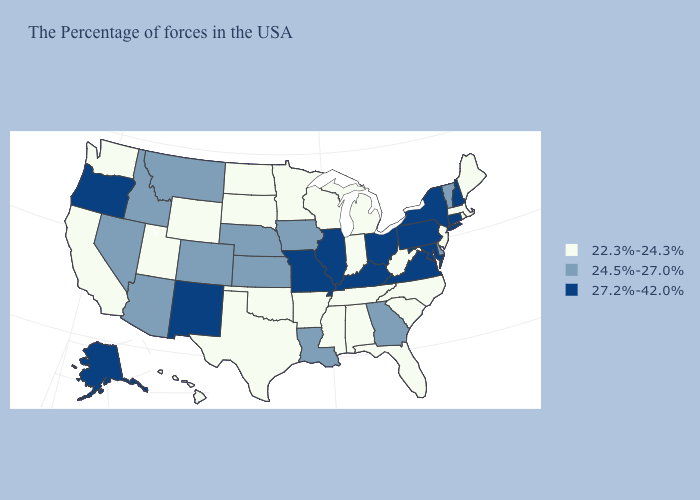Name the states that have a value in the range 24.5%-27.0%?
Be succinct. Vermont, Delaware, Georgia, Louisiana, Iowa, Kansas, Nebraska, Colorado, Montana, Arizona, Idaho, Nevada. Name the states that have a value in the range 22.3%-24.3%?
Keep it brief. Maine, Massachusetts, Rhode Island, New Jersey, North Carolina, South Carolina, West Virginia, Florida, Michigan, Indiana, Alabama, Tennessee, Wisconsin, Mississippi, Arkansas, Minnesota, Oklahoma, Texas, South Dakota, North Dakota, Wyoming, Utah, California, Washington, Hawaii. Does the map have missing data?
Quick response, please. No. Name the states that have a value in the range 24.5%-27.0%?
Concise answer only. Vermont, Delaware, Georgia, Louisiana, Iowa, Kansas, Nebraska, Colorado, Montana, Arizona, Idaho, Nevada. What is the value of Vermont?
Keep it brief. 24.5%-27.0%. Which states have the lowest value in the Northeast?
Keep it brief. Maine, Massachusetts, Rhode Island, New Jersey. What is the highest value in states that border New York?
Short answer required. 27.2%-42.0%. Which states have the lowest value in the USA?
Write a very short answer. Maine, Massachusetts, Rhode Island, New Jersey, North Carolina, South Carolina, West Virginia, Florida, Michigan, Indiana, Alabama, Tennessee, Wisconsin, Mississippi, Arkansas, Minnesota, Oklahoma, Texas, South Dakota, North Dakota, Wyoming, Utah, California, Washington, Hawaii. Among the states that border Connecticut , which have the highest value?
Be succinct. New York. What is the lowest value in the South?
Write a very short answer. 22.3%-24.3%. What is the lowest value in the USA?
Concise answer only. 22.3%-24.3%. What is the value of Washington?
Concise answer only. 22.3%-24.3%. Does Kentucky have the highest value in the USA?
Give a very brief answer. Yes. Does Oregon have the highest value in the USA?
Be succinct. Yes. Which states have the lowest value in the MidWest?
Answer briefly. Michigan, Indiana, Wisconsin, Minnesota, South Dakota, North Dakota. 